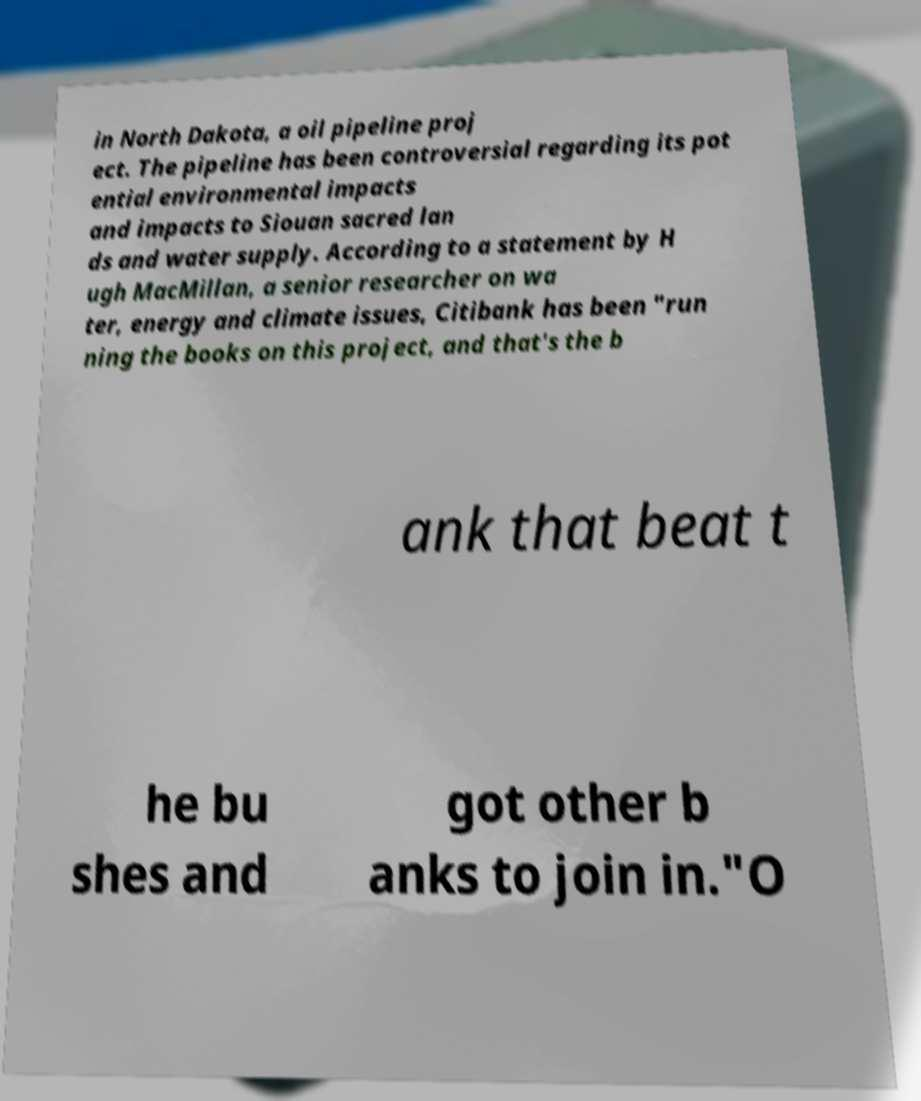I need the written content from this picture converted into text. Can you do that? in North Dakota, a oil pipeline proj ect. The pipeline has been controversial regarding its pot ential environmental impacts and impacts to Siouan sacred lan ds and water supply. According to a statement by H ugh MacMillan, a senior researcher on wa ter, energy and climate issues, Citibank has been "run ning the books on this project, and that's the b ank that beat t he bu shes and got other b anks to join in."O 